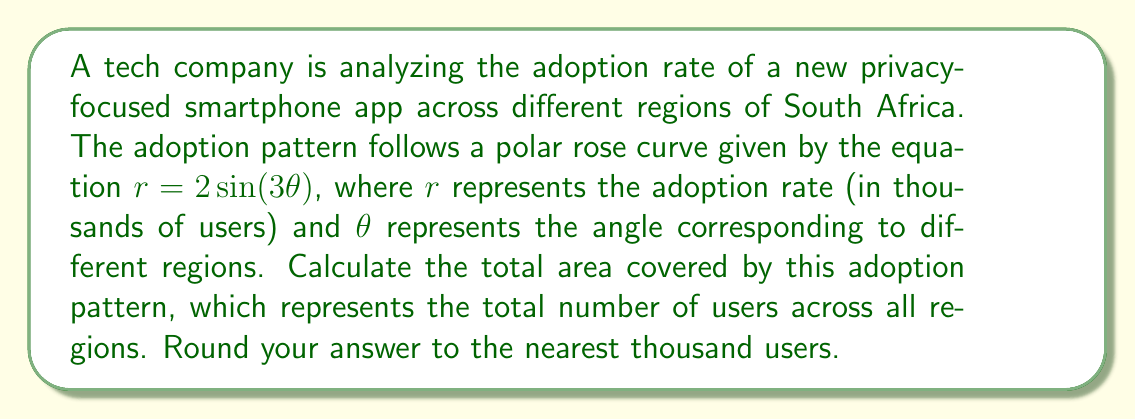Can you answer this question? To solve this problem, we need to follow these steps:

1) The area of a polar rose with $n$ petals is given by the formula:

   $$A = \frac{n}{4} \int_0^{2\pi} r^2 d\theta$$

   where $n$ is the number of petals.

2) In our case, $r = 2\sin(3\theta)$, and we can see that $n = 3$ (because of the $3\theta$ in the sine function).

3) Let's substitute these into the formula:

   $$A = \frac{3}{4} \int_0^{2\pi} (2\sin(3\theta))^2 d\theta$$

4) Simplify the integrand:

   $$A = 3 \int_0^{2\pi} \sin^2(3\theta) d\theta$$

5) We can use the trigonometric identity $\sin^2(x) = \frac{1 - \cos(2x)}{2}$:

   $$A = 3 \int_0^{2\pi} \frac{1 - \cos(6\theta)}{2} d\theta$$

6) Simplify:

   $$A = \frac{3}{2} \int_0^{2\pi} (1 - \cos(6\theta)) d\theta$$

7) Integrate:

   $$A = \frac{3}{2} [\theta - \frac{1}{6}\sin(6\theta)]_0^{2\pi}$$

8) Evaluate the integral:

   $$A = \frac{3}{2} [(2\pi - 0) - (\frac{1}{6}\sin(12\pi) - \frac{1}{6}\sin(0))]$$

9) Simplify:

   $$A = 3\pi$$

10) The area represents thousands of users, so we multiply by 1000:

    $$\text{Total users} = 3\pi * 1000 \approx 9425$$

11) Rounding to the nearest thousand:

    $$\text{Total users} \approx 9000$$
Answer: 9000 users 